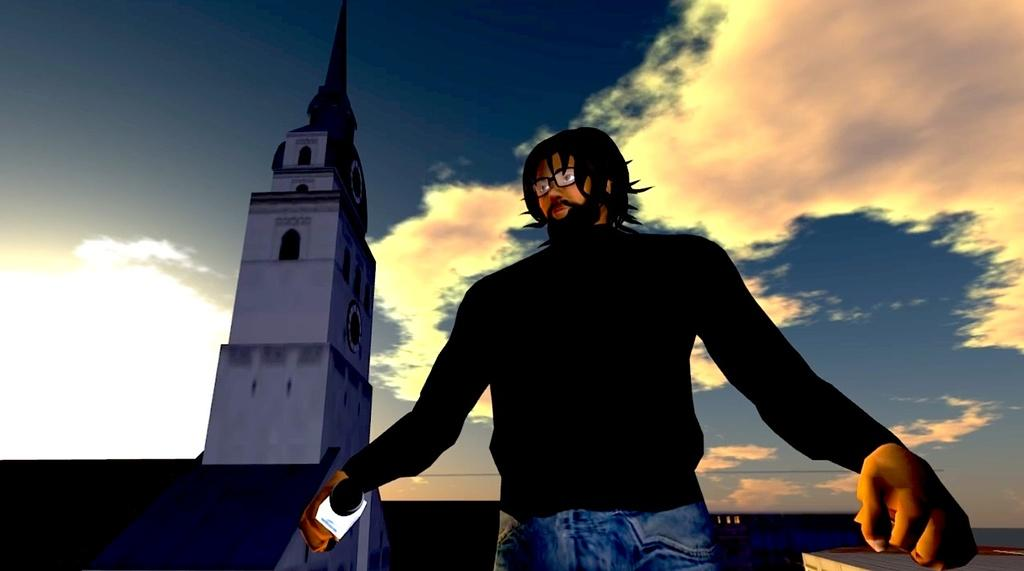What is the person in the image holding? The person is holding a mic in the image. What type of image is this? The image is animated. What structure can be seen in the image? There is a building in the image. What is visible in the background of the image? The sky is visible in the image, and clouds are present in the sky. How many cent wrens are perched on the building in the image? There are no cent wrens present in the image, and the image does not depict any birds or animals. 